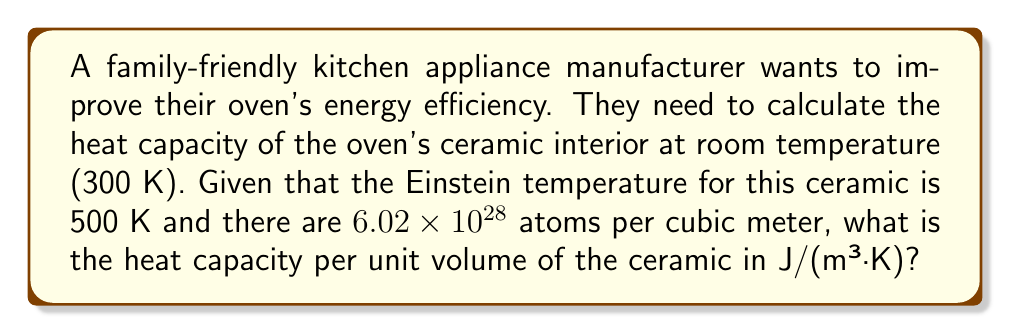Show me your answer to this math problem. Let's approach this step-by-step using the Einstein model:

1) The Einstein model gives the heat capacity per atom as:

   $$C_V = 3k_B \left(\frac{\theta_E}{T}\right)^2 \frac{e^{\theta_E/T}}{(e^{\theta_E/T}-1)^2}$$

   where $k_B$ is Boltzmann's constant, $\theta_E$ is the Einstein temperature, and $T$ is the temperature.

2) Given:
   - $\theta_E = 500$ K
   - $T = 300$ K
   - $k_B = 1.38 \times 10^{-23}$ J/K

3) Let's substitute these values:

   $$C_V = 3(1.38 \times 10^{-23}) \left(\frac{500}{300}\right)^2 \frac{e^{500/300}}{(e^{500/300}-1)^2}$$

4) Simplify:
   $$C_V = 4.14 \times 10^{-23} \cdot \frac{25}{9} \cdot \frac{e^{5/3}}{(e^{5/3}-1)^2}$$

5) Calculate:
   $$C_V \approx 3.04 \times 10^{-23}$$ J/K per atom

6) To get the heat capacity per unit volume, multiply by the number of atoms per cubic meter:

   $$C_V(\text{per m}^3) = (3.04 \times 10^{-23})(6.02 \times 10^{28}) \approx 1.83 \times 10^6$$ J/(m³·K)
Answer: $1.83 \times 10^6$ J/(m³·K) 